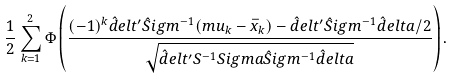<formula> <loc_0><loc_0><loc_500><loc_500>\frac { 1 } { 2 } \sum _ { k = 1 } ^ { 2 } \Phi \left ( \frac { ( - 1 ) ^ { k } \hat { d } e l t ^ { \prime } \hat { S } i g m ^ { - 1 } ( m u _ { k } - \bar { x } _ { k } ) - \hat { d } e l t ^ { \prime } \hat { S } i g m ^ { - 1 } \hat { d } e l t a / 2 } { \sqrt { \hat { d } e l t ^ { \prime } S ^ { - 1 } S i g m a \hat { S } i g m ^ { - 1 } \hat { d } e l t a } } \right ) .</formula> 